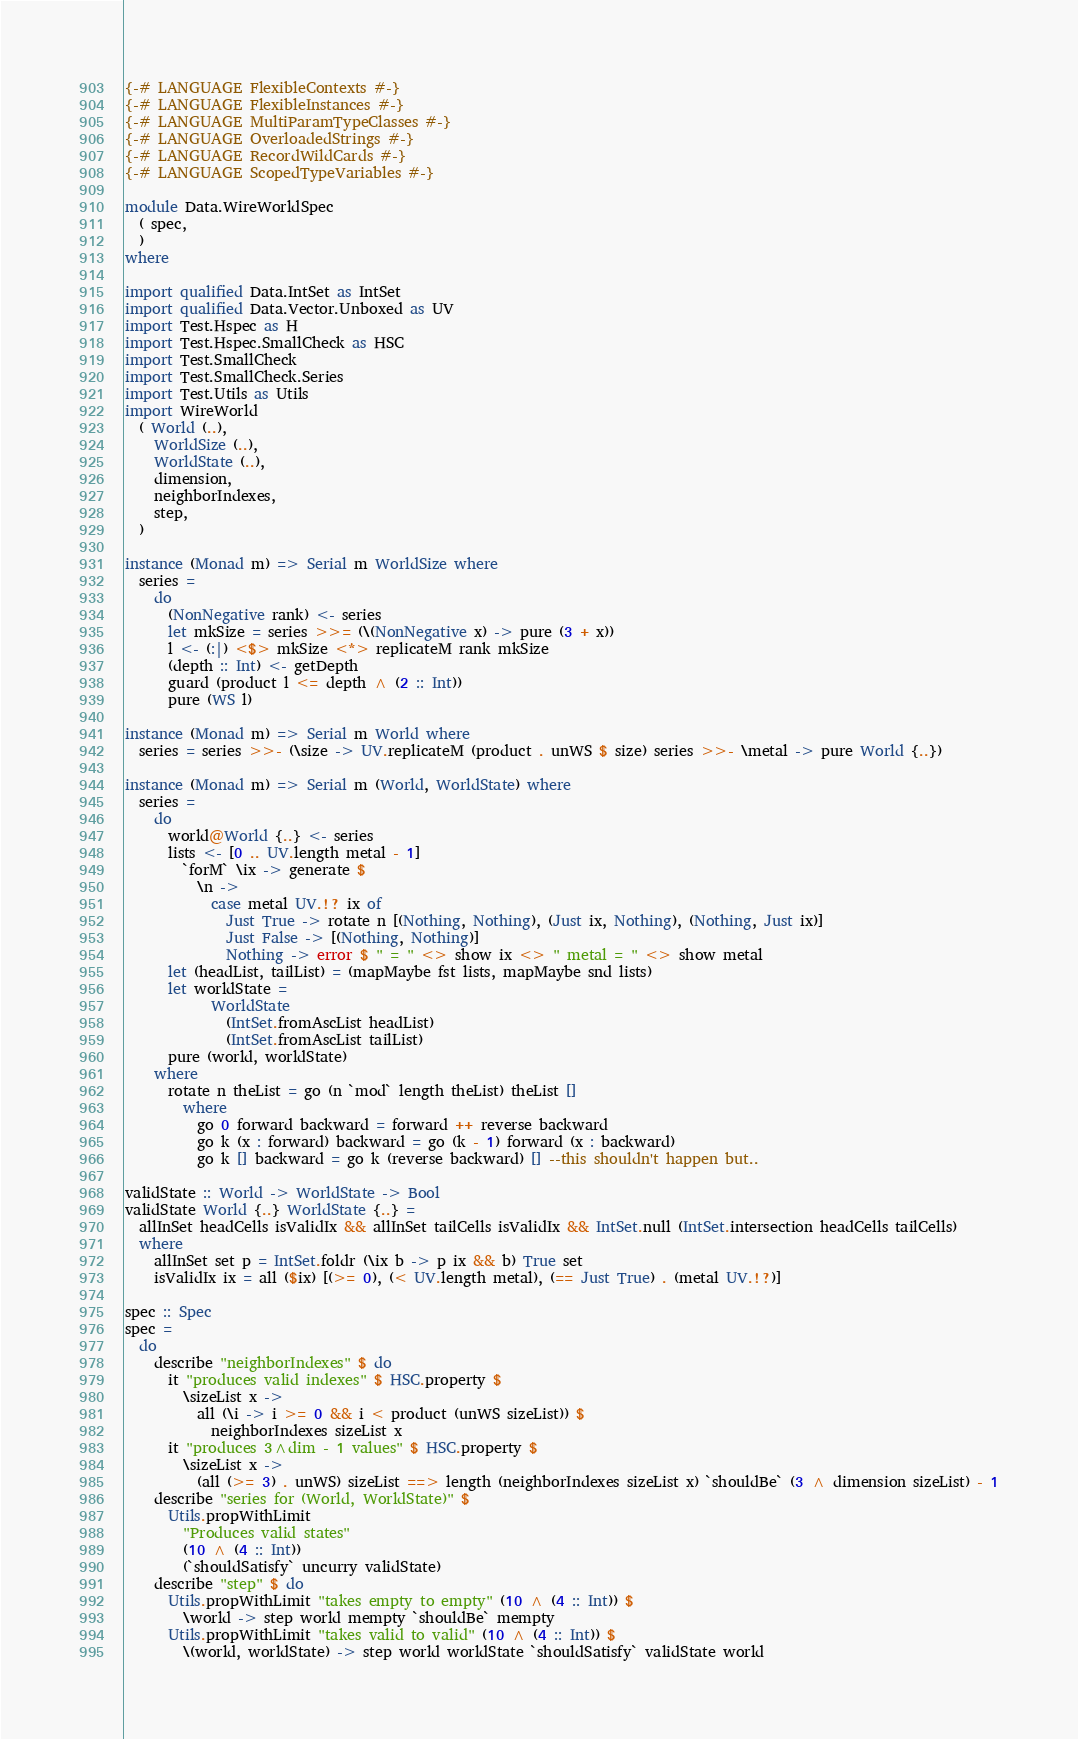Convert code to text. <code><loc_0><loc_0><loc_500><loc_500><_Haskell_>{-# LANGUAGE FlexibleContexts #-}
{-# LANGUAGE FlexibleInstances #-}
{-# LANGUAGE MultiParamTypeClasses #-}
{-# LANGUAGE OverloadedStrings #-}
{-# LANGUAGE RecordWildCards #-}
{-# LANGUAGE ScopedTypeVariables #-}

module Data.WireWorldSpec
  ( spec,
  )
where

import qualified Data.IntSet as IntSet
import qualified Data.Vector.Unboxed as UV
import Test.Hspec as H
import Test.Hspec.SmallCheck as HSC
import Test.SmallCheck
import Test.SmallCheck.Series
import Test.Utils as Utils
import WireWorld
  ( World (..),
    WorldSize (..),
    WorldState (..),
    dimension,
    neighborIndexes,
    step,
  )

instance (Monad m) => Serial m WorldSize where
  series =
    do
      (NonNegative rank) <- series
      let mkSize = series >>= (\(NonNegative x) -> pure (3 + x))
      l <- (:|) <$> mkSize <*> replicateM rank mkSize
      (depth :: Int) <- getDepth
      guard (product l <= depth ^ (2 :: Int))
      pure (WS l)

instance (Monad m) => Serial m World where
  series = series >>- (\size -> UV.replicateM (product . unWS $ size) series >>- \metal -> pure World {..})

instance (Monad m) => Serial m (World, WorldState) where
  series =
    do
      world@World {..} <- series
      lists <- [0 .. UV.length metal - 1]
        `forM` \ix -> generate $
          \n ->
            case metal UV.!? ix of
              Just True -> rotate n [(Nothing, Nothing), (Just ix, Nothing), (Nothing, Just ix)]
              Just False -> [(Nothing, Nothing)]
              Nothing -> error $ " = " <> show ix <> " metal = " <> show metal
      let (headList, tailList) = (mapMaybe fst lists, mapMaybe snd lists)
      let worldState =
            WorldState
              (IntSet.fromAscList headList)
              (IntSet.fromAscList tailList)
      pure (world, worldState)
    where
      rotate n theList = go (n `mod` length theList) theList []
        where
          go 0 forward backward = forward ++ reverse backward
          go k (x : forward) backward = go (k - 1) forward (x : backward)
          go k [] backward = go k (reverse backward) [] --this shouldn't happen but..

validState :: World -> WorldState -> Bool
validState World {..} WorldState {..} =
  allInSet headCells isValidIx && allInSet tailCells isValidIx && IntSet.null (IntSet.intersection headCells tailCells)
  where
    allInSet set p = IntSet.foldr (\ix b -> p ix && b) True set
    isValidIx ix = all ($ix) [(>= 0), (< UV.length metal), (== Just True) . (metal UV.!?)]

spec :: Spec
spec =
  do
    describe "neighborIndexes" $ do
      it "produces valid indexes" $ HSC.property $
        \sizeList x ->
          all (\i -> i >= 0 && i < product (unWS sizeList)) $
            neighborIndexes sizeList x
      it "produces 3^dim - 1 values" $ HSC.property $
        \sizeList x ->
          (all (>= 3) . unWS) sizeList ==> length (neighborIndexes sizeList x) `shouldBe` (3 ^ dimension sizeList) - 1
    describe "series for (World, WorldState)" $
      Utils.propWithLimit
        "Produces valid states"
        (10 ^ (4 :: Int))
        (`shouldSatisfy` uncurry validState)
    describe "step" $ do
      Utils.propWithLimit "takes empty to empty" (10 ^ (4 :: Int)) $
        \world -> step world mempty `shouldBe` mempty
      Utils.propWithLimit "takes valid to valid" (10 ^ (4 :: Int)) $
        \(world, worldState) -> step world worldState `shouldSatisfy` validState world
</code> 